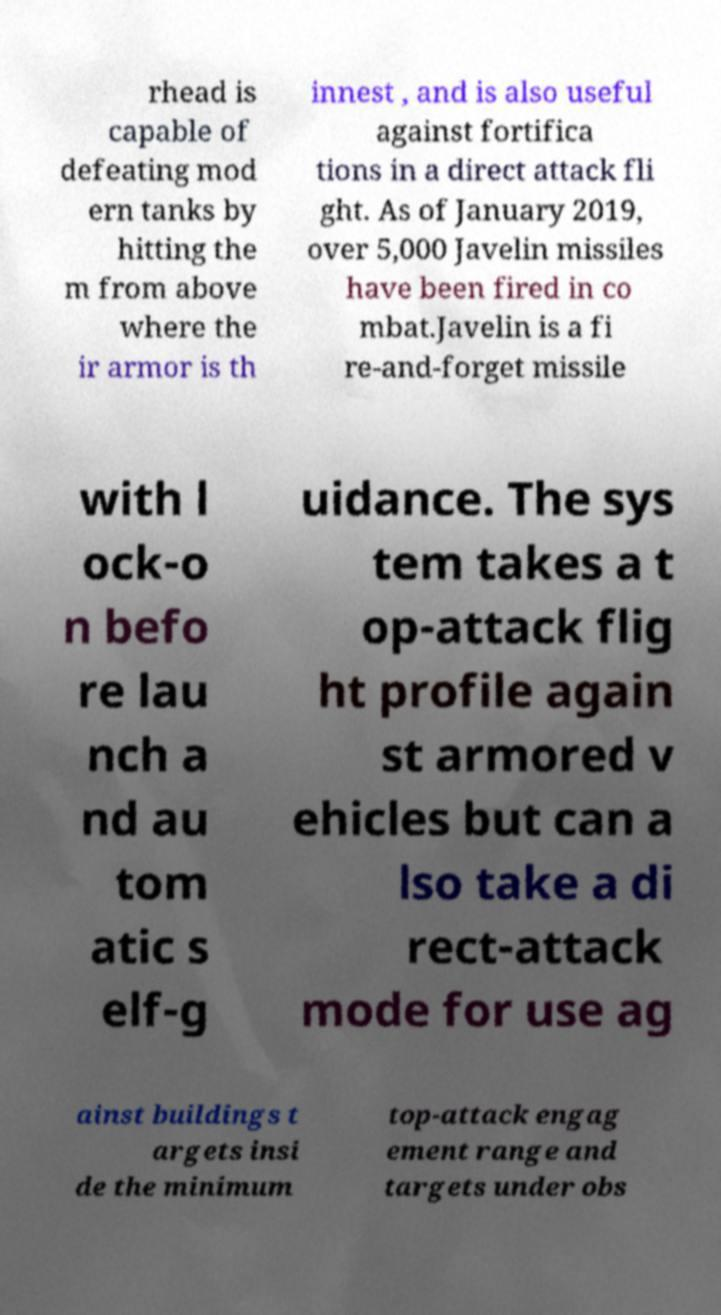Could you assist in decoding the text presented in this image and type it out clearly? rhead is capable of defeating mod ern tanks by hitting the m from above where the ir armor is th innest , and is also useful against fortifica tions in a direct attack fli ght. As of January 2019, over 5,000 Javelin missiles have been fired in co mbat.Javelin is a fi re-and-forget missile with l ock-o n befo re lau nch a nd au tom atic s elf-g uidance. The sys tem takes a t op-attack flig ht profile again st armored v ehicles but can a lso take a di rect-attack mode for use ag ainst buildings t argets insi de the minimum top-attack engag ement range and targets under obs 